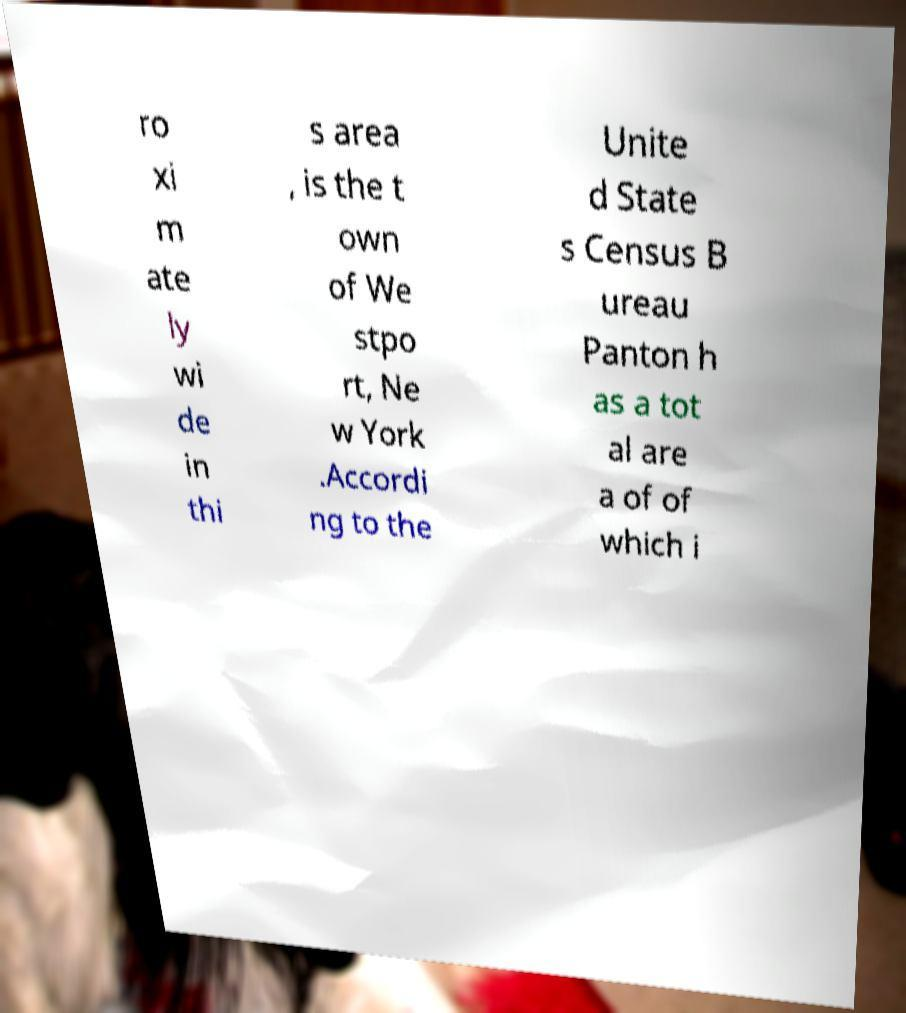There's text embedded in this image that I need extracted. Can you transcribe it verbatim? ro xi m ate ly wi de in thi s area , is the t own of We stpo rt, Ne w York .Accordi ng to the Unite d State s Census B ureau Panton h as a tot al are a of of which i 